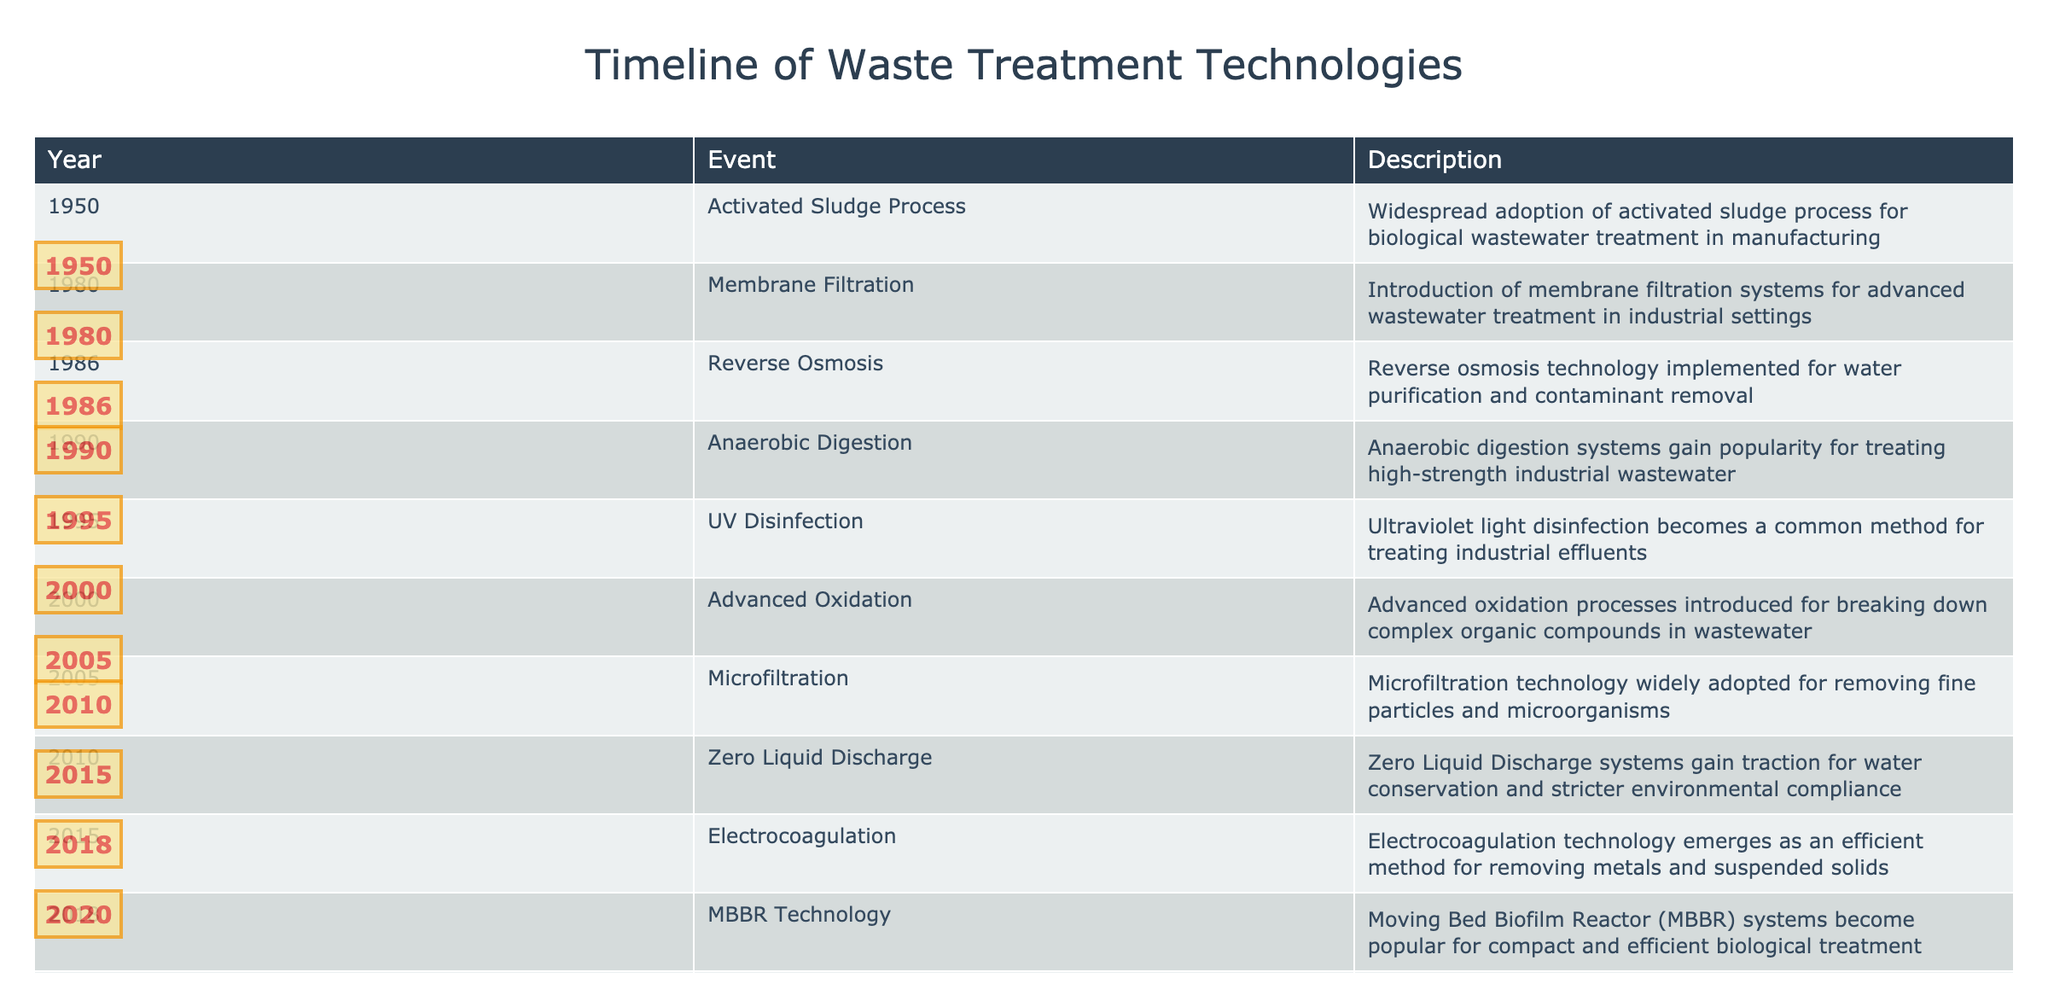What year was the Activated Sludge Process widely adopted? According to the table, the event of adopting the Activated Sludge Process occurred in 1950.
Answer: 1950 What are the two waste treatment technologies introduced in the 2000s? From the table, the two technologies are Advanced Oxidation introduced in 2000 and Electrocoagulation introduced in 2015.
Answer: Advanced Oxidation and Electrocoagulation Which waste treatment technology was adopted first, Membrane Filtration or Reverse Osmosis? The table shows that Membrane Filtration was introduced in 1980 and Reverse Osmosis in 1986. Since 1980 is earlier than 1986, Membrane Filtration was adopted first.
Answer: Membrane Filtration What percentage of the listed technologies were adopted after 2000? There are 5 technologies after 2000 out of a total of 10. The percentage is (5/10) * 100 = 50%.
Answer: 50% Did the use of UV Disinfection occur before or after Anaerobic Digestion? The table lists Anaerobic Digestion in 1990 and UV Disinfection in 1995. Since 1990 is prior to 1995, UV Disinfection occurred after Anaerobic Digestion.
Answer: After Which technology introduced in 2010 focuses on water conservation? The table indicates that Zero Liquid Discharge, introduced in 2010, focuses on water conservation and compliance.
Answer: Zero Liquid Discharge What was the last technology introduced before IoT integration in 2020? According to the timeline, the last technology before IoT integration in 2020 is MBBR Technology, which was adopted in 2018.
Answer: MBBR Technology How many years apart were the introductions of Membrane Filtration and Microfiltration? Membrane Filtration was introduced in 1980 and Microfiltration in 2005. Therefore, the difference between 2005 and 1980 is 25 years.
Answer: 25 years What is the trend in waste treatment technology adoption from 1950 to 2020? Analyzing the years given in the timeline, we can observe that technological advancements in waste treatment have accelerated, with more technologies introduced in more recent years, particularly after 2000.
Answer: Increasing trend 